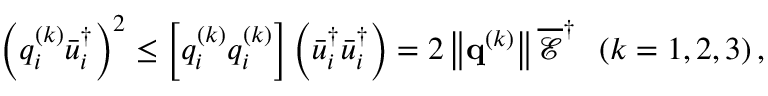Convert formula to latex. <formula><loc_0><loc_0><loc_500><loc_500>{ \left ( { q _ { i } ^ { \left ( k \right ) } \bar { u } _ { i } ^ { \dag } } \right ) ^ { 2 } } \leq \left [ { q _ { i } ^ { \left ( k \right ) } q _ { i } ^ { \left ( k \right ) } } \right ] \left ( { \bar { u } _ { i } ^ { \dag } \bar { u } _ { i } ^ { \dag } } \right ) = 2 \left \| { { { q } ^ { \left ( k \right ) } } } \right \| \overline { \mathcal { E } } ^ { \dag } \, \left ( { k = 1 , 2 , 3 } \right ) ,</formula> 